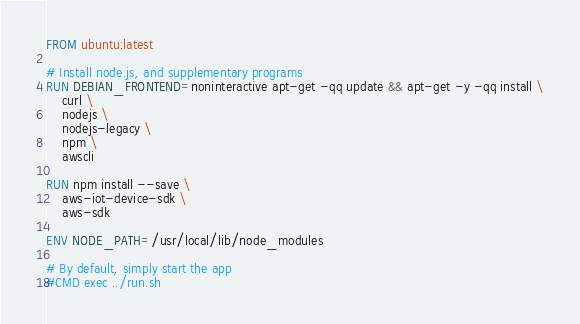Convert code to text. <code><loc_0><loc_0><loc_500><loc_500><_Dockerfile_>FROM ubuntu:latest

# Install node.js, and supplementary programs
RUN DEBIAN_FRONTEND=noninteractive apt-get -qq update && apt-get -y -qq install \
	curl \
	nodejs \
	nodejs-legacy \
	npm \
	awscli
	
RUN npm install --save \
	aws-iot-device-sdk \
	aws-sdk

ENV NODE_PATH=/usr/local/lib/node_modules

# By default, simply start the app
#CMD exec ../run.sh
</code> 